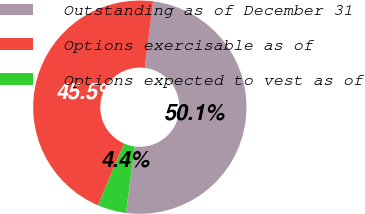Convert chart. <chart><loc_0><loc_0><loc_500><loc_500><pie_chart><fcel>Outstanding as of December 31<fcel>Options exercisable as of<fcel>Options expected to vest as of<nl><fcel>50.09%<fcel>45.54%<fcel>4.36%<nl></chart> 